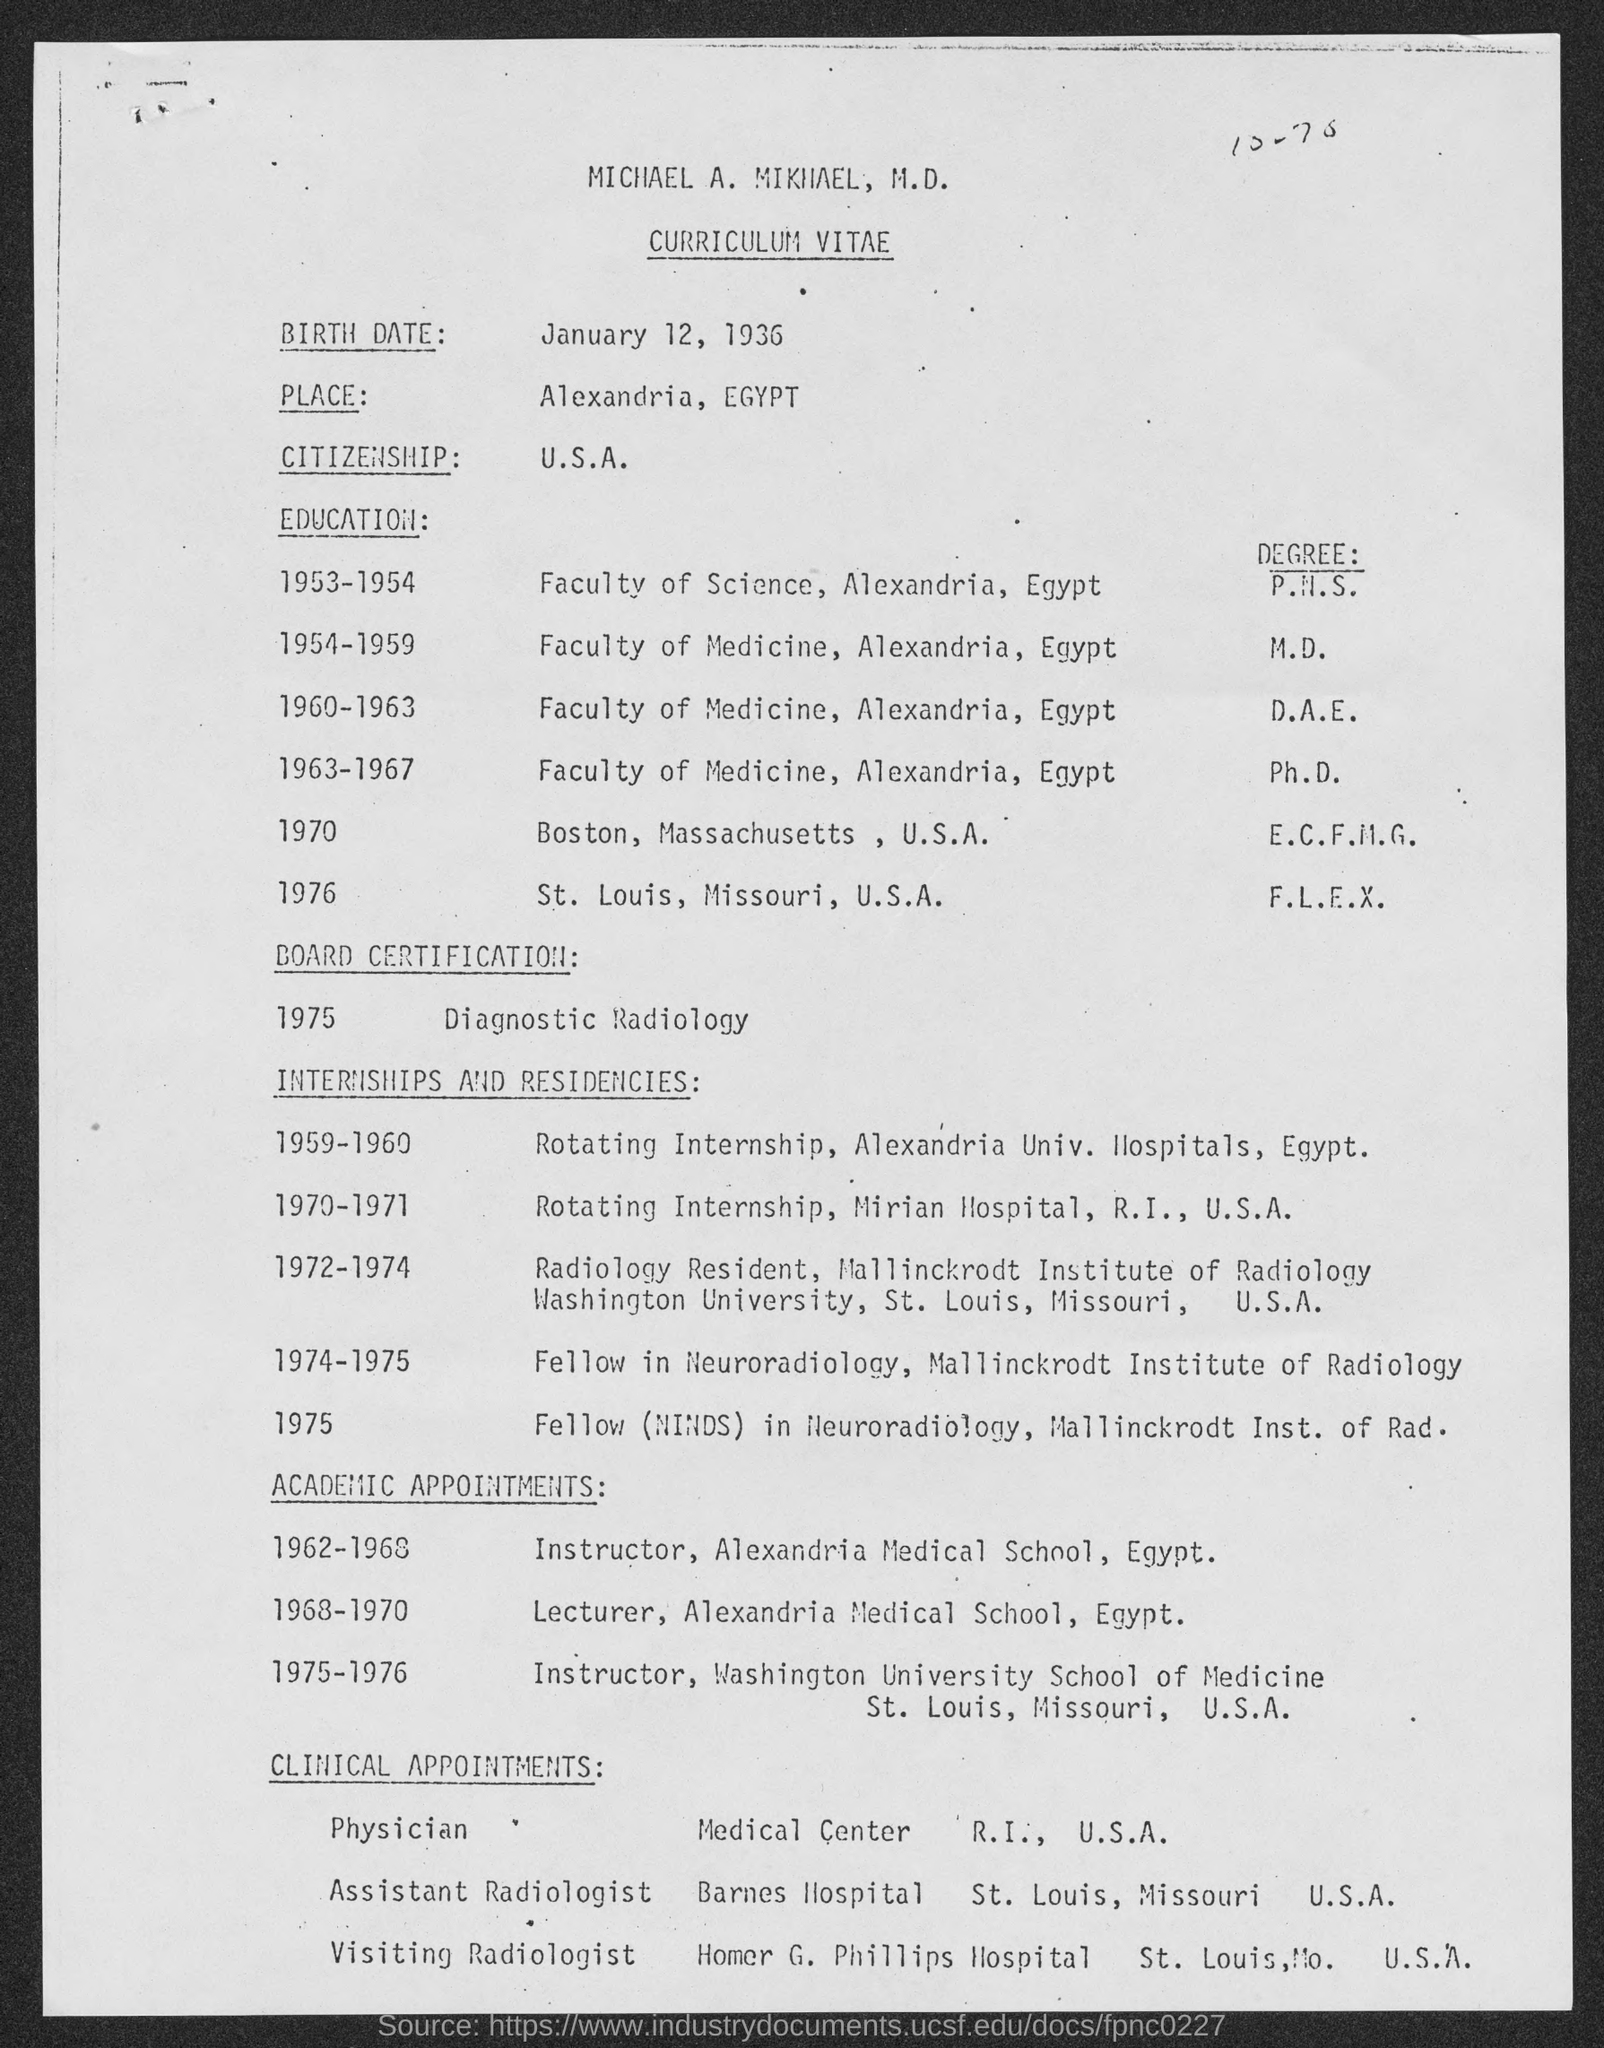List a handful of essential elements in this visual. The birthdate of Michael A. Mikhael is January 12, 1936. Michael has completed his degree in F.L.E.X at St. Louis, Missouri, in the United States of America. Michael's citizenship is U.S.A. 